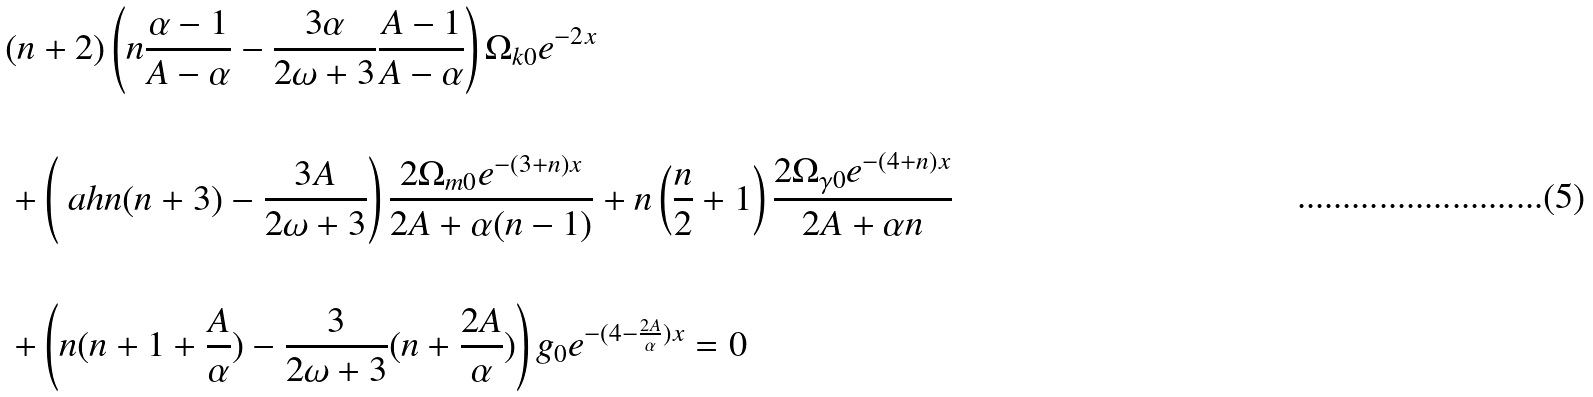Convert formula to latex. <formula><loc_0><loc_0><loc_500><loc_500>& ( n + 2 ) \left ( n \frac { \alpha - 1 } { A - \alpha } - \frac { 3 \alpha } { 2 \omega + 3 } \frac { A - 1 } { A - \alpha } \right ) \Omega _ { k 0 } e ^ { - 2 x } \\ & \\ & + \left ( \ a h n ( n + 3 ) - \frac { 3 A } { 2 \omega + 3 } \right ) \frac { 2 \Omega _ { m 0 } e ^ { - ( 3 + n ) x } } { 2 A + \alpha ( n - 1 ) } + n \left ( \frac { n } { 2 } + 1 \right ) \frac { 2 \Omega _ { \gamma 0 } e ^ { - ( 4 + n ) x } } { 2 A + \alpha n } \\ & \\ & + \left ( n ( n + 1 + \frac { A } { \alpha } ) - \frac { 3 } { 2 \omega + 3 } ( n + \frac { 2 A } { \alpha } ) \right ) g _ { 0 } e ^ { - ( 4 - \frac { 2 A } { \alpha } ) x } = 0 \\</formula> 